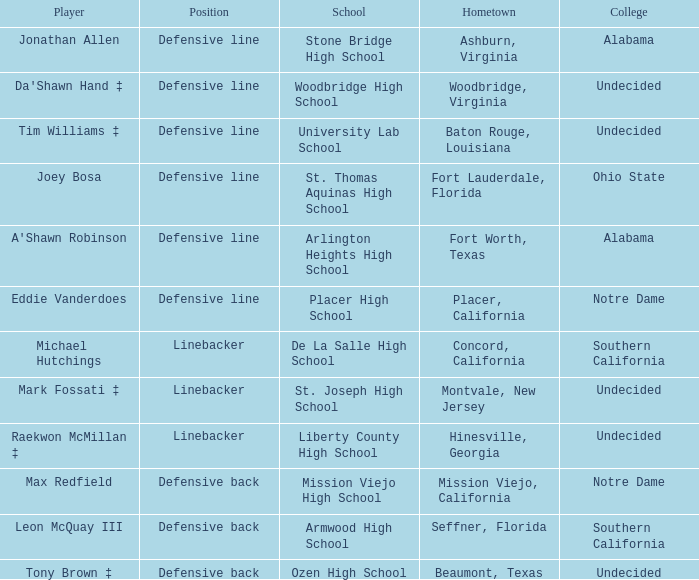What position did Max Redfield play? Defensive back. 